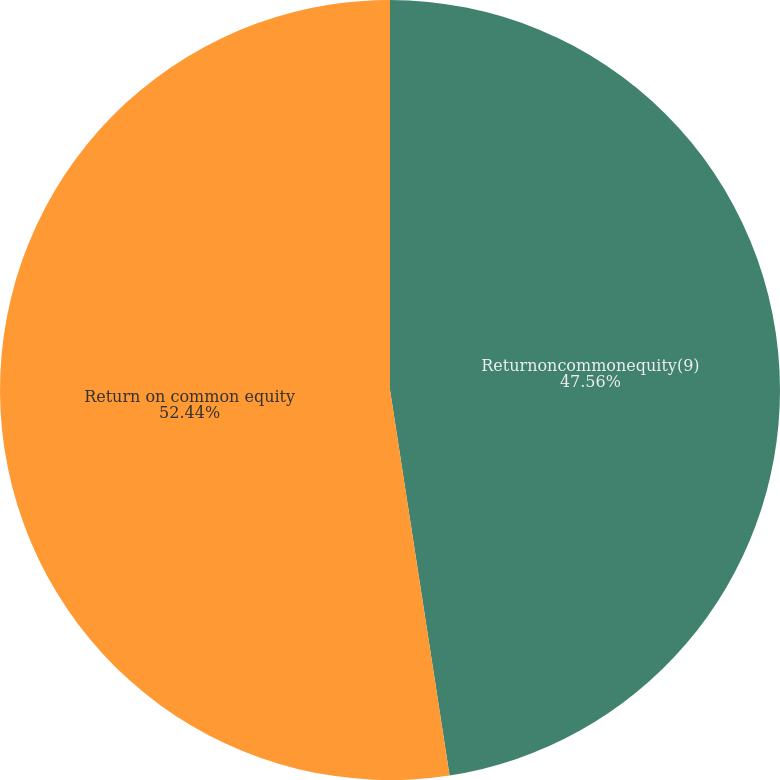Convert chart to OTSL. <chart><loc_0><loc_0><loc_500><loc_500><pie_chart><fcel>Returnoncommonequity(9)<fcel>Return on common equity<nl><fcel>47.56%<fcel>52.44%<nl></chart> 